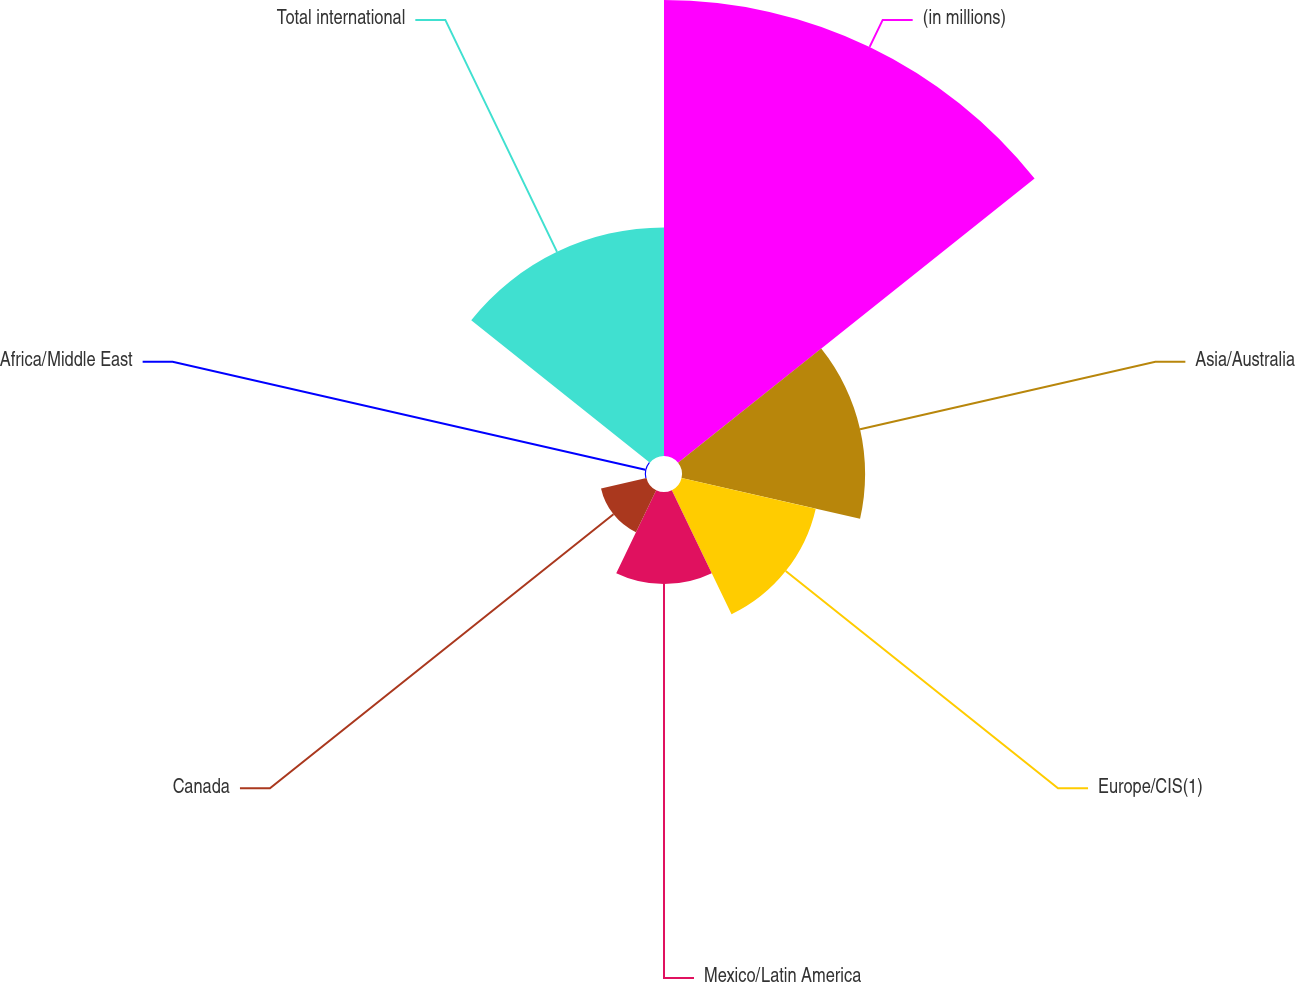Convert chart. <chart><loc_0><loc_0><loc_500><loc_500><pie_chart><fcel>(in millions)<fcel>Asia/Australia<fcel>Europe/CIS(1)<fcel>Mexico/Latin America<fcel>Canada<fcel>Africa/Middle East<fcel>Total international<nl><fcel>39.82%<fcel>15.99%<fcel>12.02%<fcel>8.04%<fcel>4.07%<fcel>0.1%<fcel>19.96%<nl></chart> 